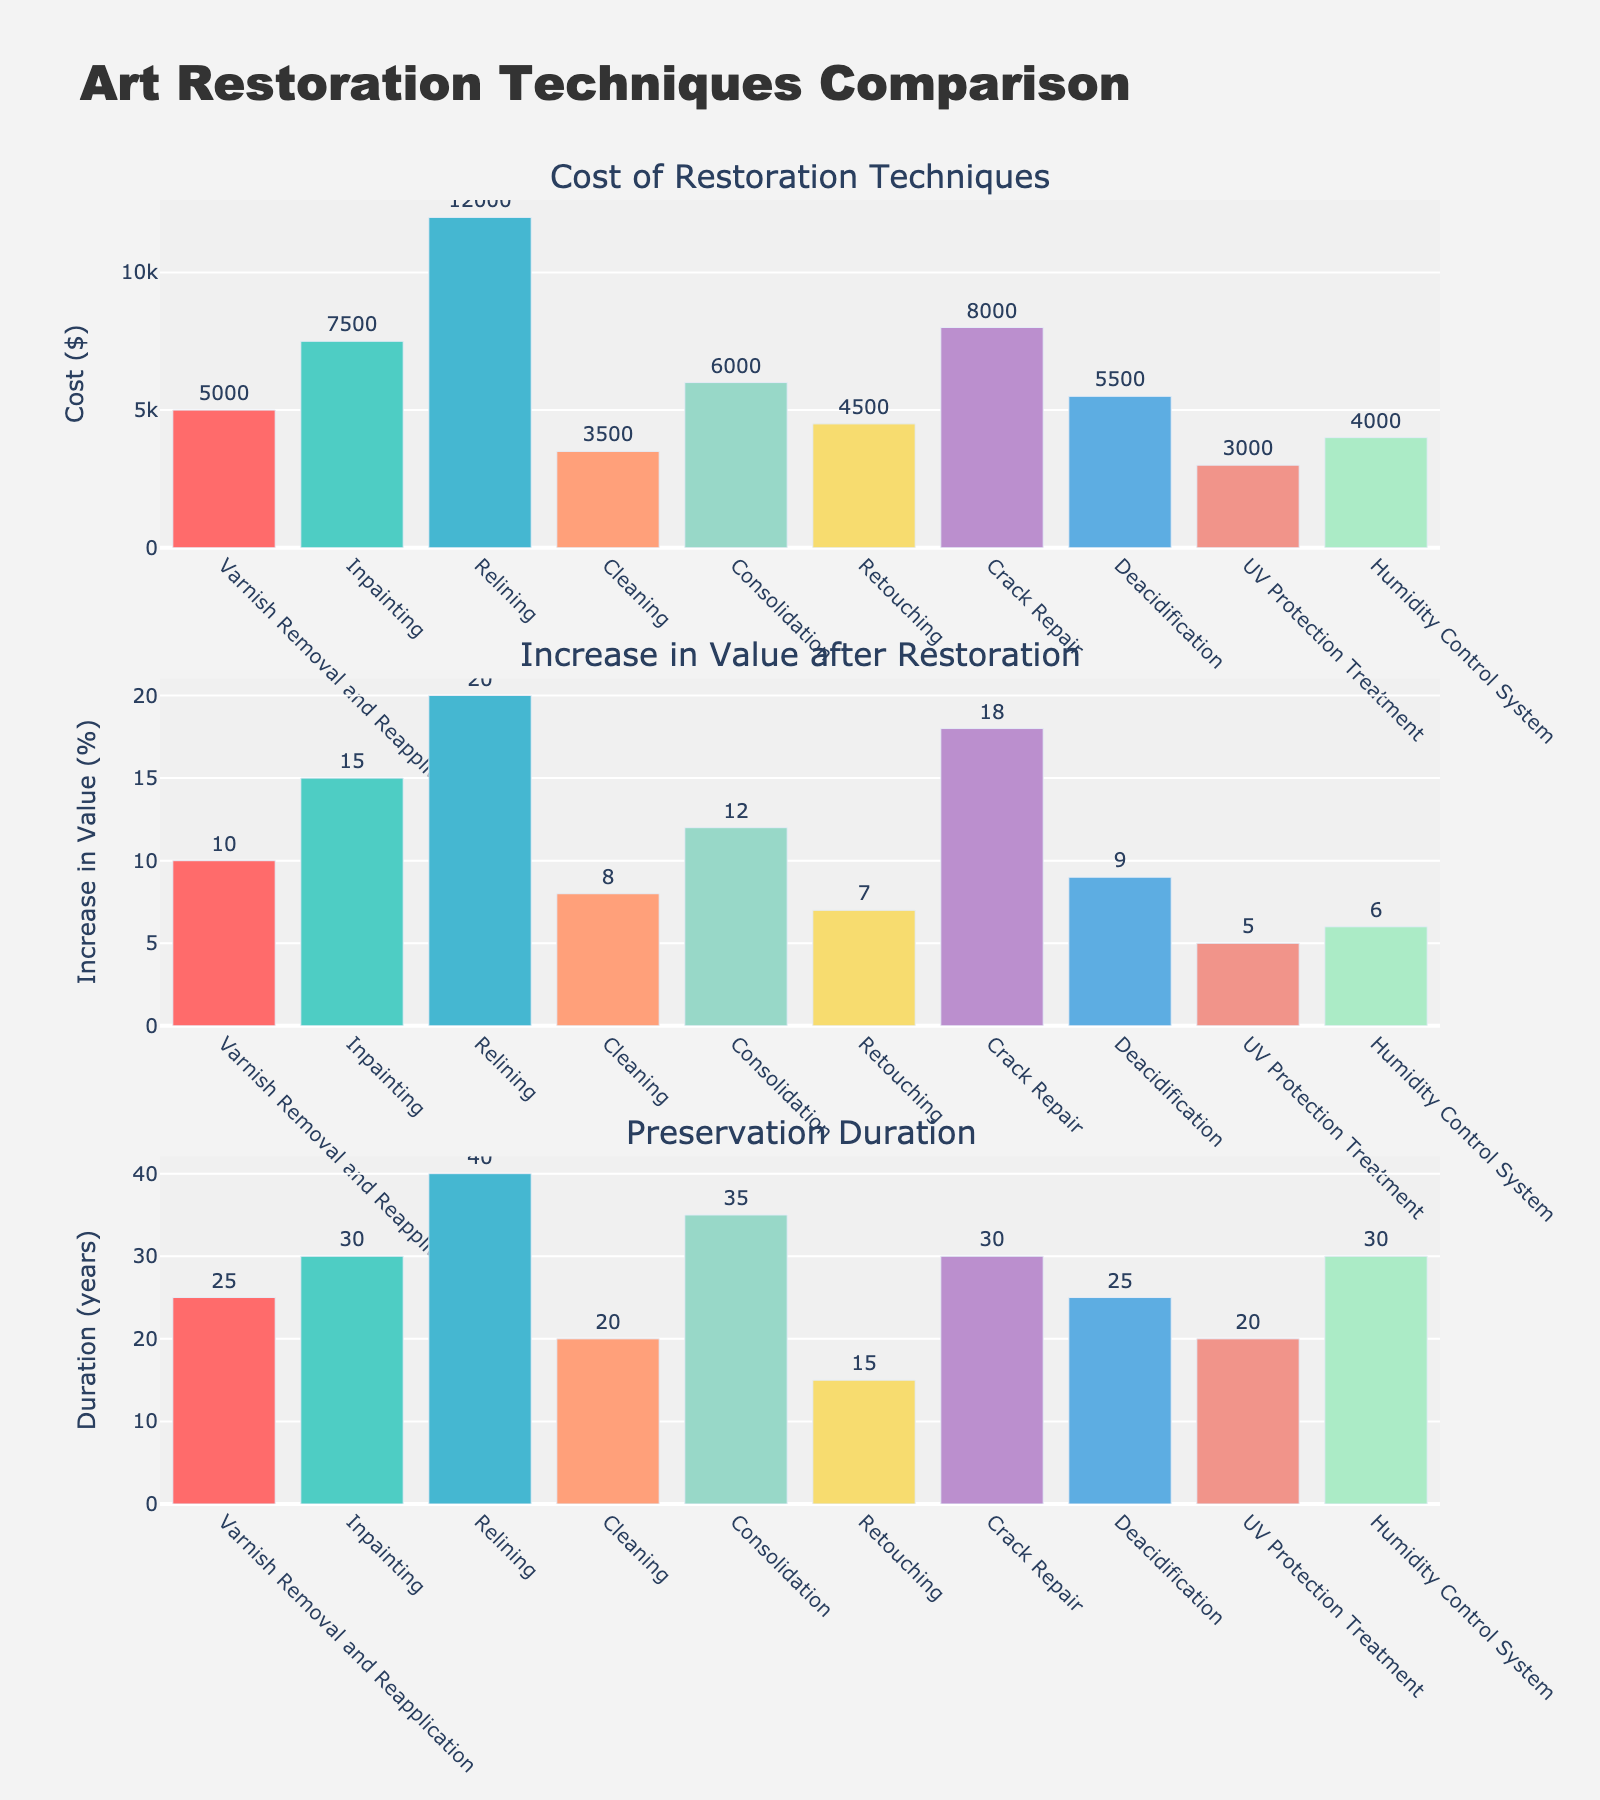What is the title of the figure? The title is usually at the top of the figure. Looking at the top of the figure, the title "Evolution of Prison Populations (1990-2020)" is present.
Answer: Evolution of Prison Populations (1990-2020) How many countries are represented in the figure? Count the number of subplot titles, each corresponding to a country. There are six countries in the figure.
Answer: 6 Which country had the highest incarceration rate in 2010? Look at the bubbles representing 2010. The size reflects the incarceration rate. The United States has the largest bubble in 2010.
Answer: United States What is the trend in prison population for Japan from 1990 to 2020? Observe the vertical trends for Japan across the years. The prison population increased from 1990 to 2010 and then decreased by 2020.
Answer: Increase then decrease Which country experienced the largest increase in prison population size from 1990 to 2020? Calculate the difference in prison population from 1990 to 2020 for each country. Brazil shows the largest increase from 90,000 to 759,518.
Answer: Brazil How does the incarceration rate trend for Norway differ from the United States between 1990 and 2020? Compare the bubble sizes for Norway and the United States over time. Norway's rate increases slightly while the United States' rises sharply then decreases by 2020.
Answer: US: Sharply up, then down; Norway: Slight up What is the prison population of Russia in 2000? Locate the bubble for Russia in 2000. The data label indicates 1,060,401.
Answer: 1,060,401 Compare the incarceration rate of Russia and Brazil in 2020. Which is higher? Compare the bubble sizes for Russia and Brazil in 2020. Brazil's bubble is larger, indicating a higher rate.
Answer: Brazil What is the maximum prison population for the United Kingdom between 1990 and 2020? Find the highest y-value for the United Kingdom. In 2010, it is 85,002.
Answer: 85,002 What can be inferred about the prison population trend in the United States from 2000 to 2020? Observe the y-values in the corresponding time. It increased steeply from 2000 to 2010 then decreased by 2020.
Answer: Increased then decreased 